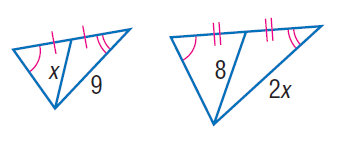Answer the mathemtical geometry problem and directly provide the correct option letter.
Question: Find x.
Choices: A: 5 B: 6 C: 7 D: 8 B 